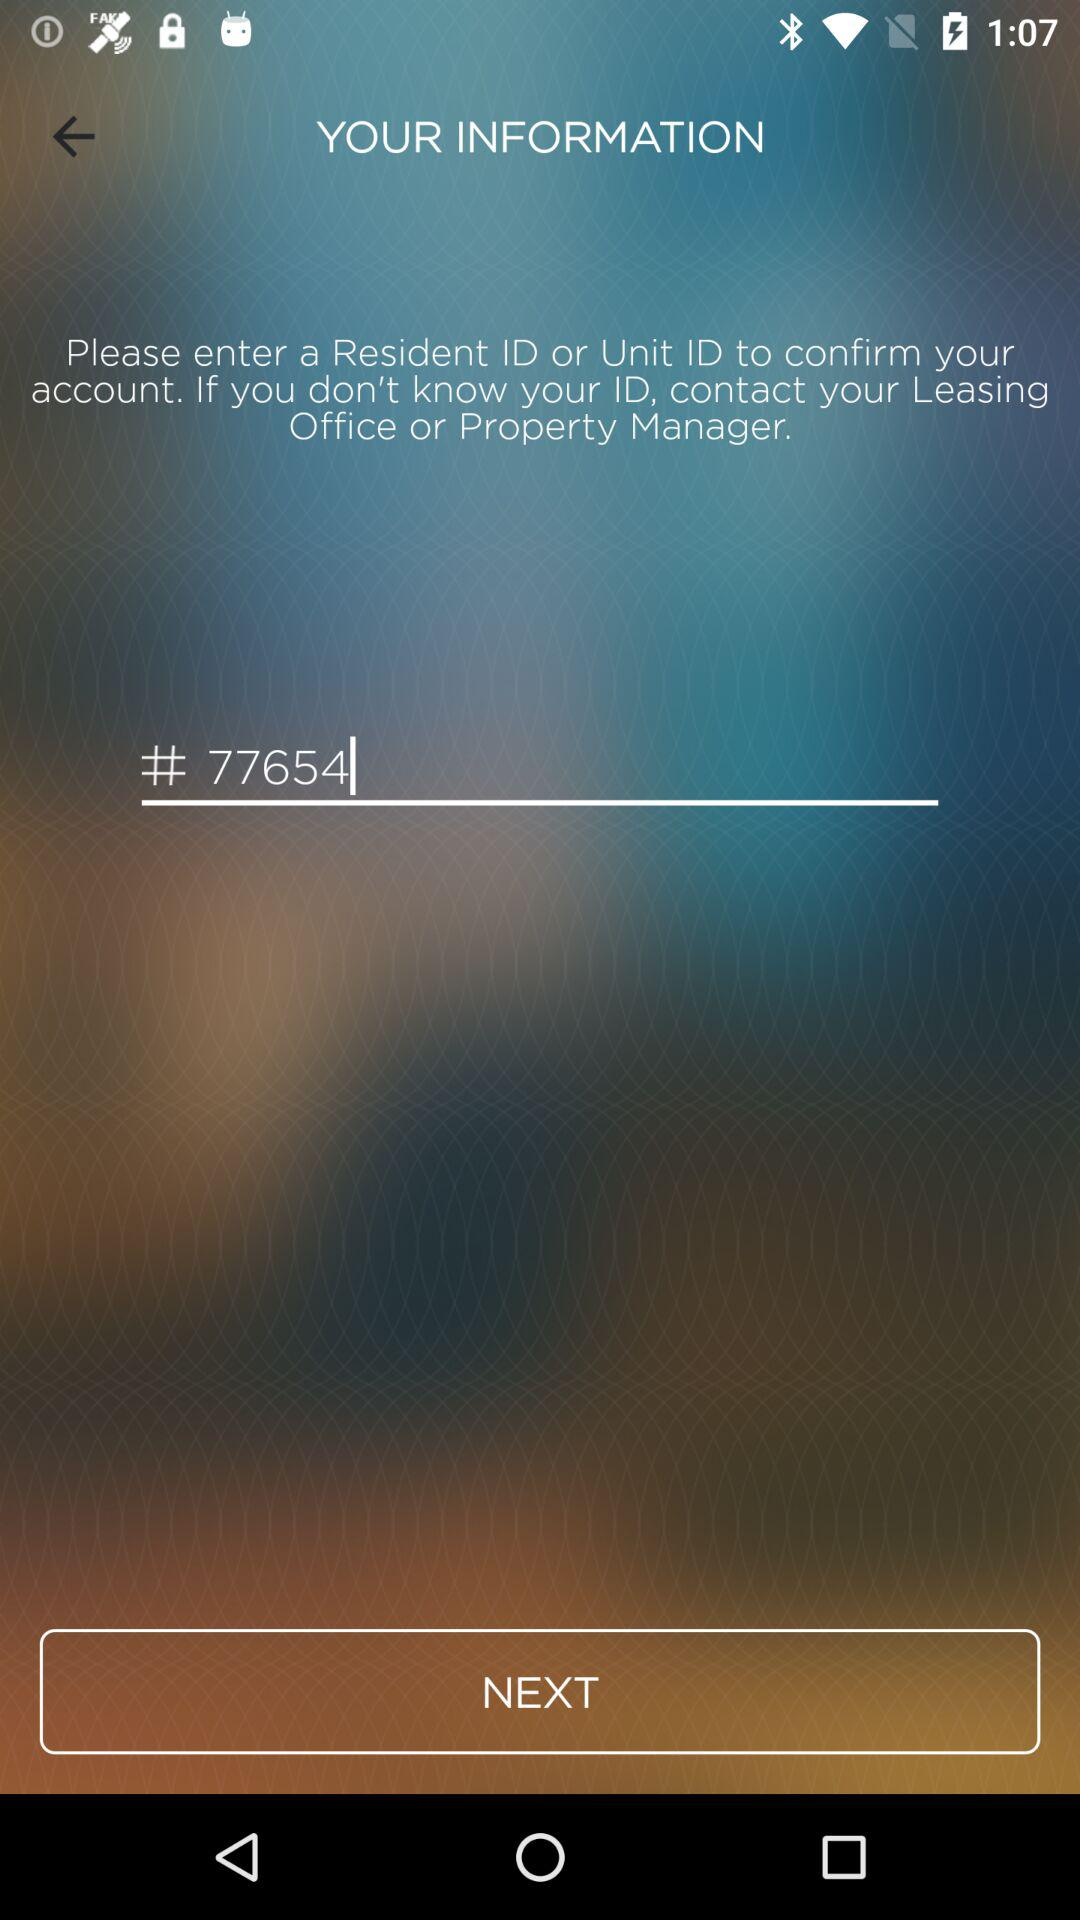How many digits are in the text input?
Answer the question using a single word or phrase. 5 